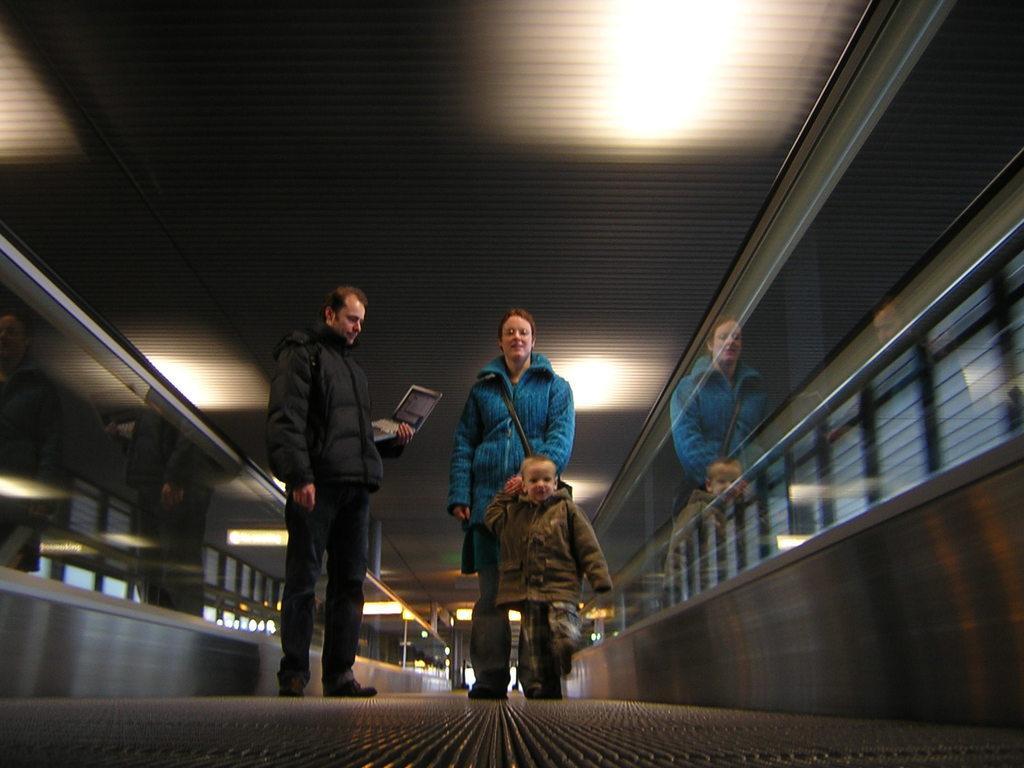In one or two sentences, can you explain what this image depicts? In the image there are three persons standing. There is a man holding a laptop in his hand. On the sides of the image there is railing. Behind the railing on the left side there are glass walls. At the top of the image there is a ceiling with lights. 